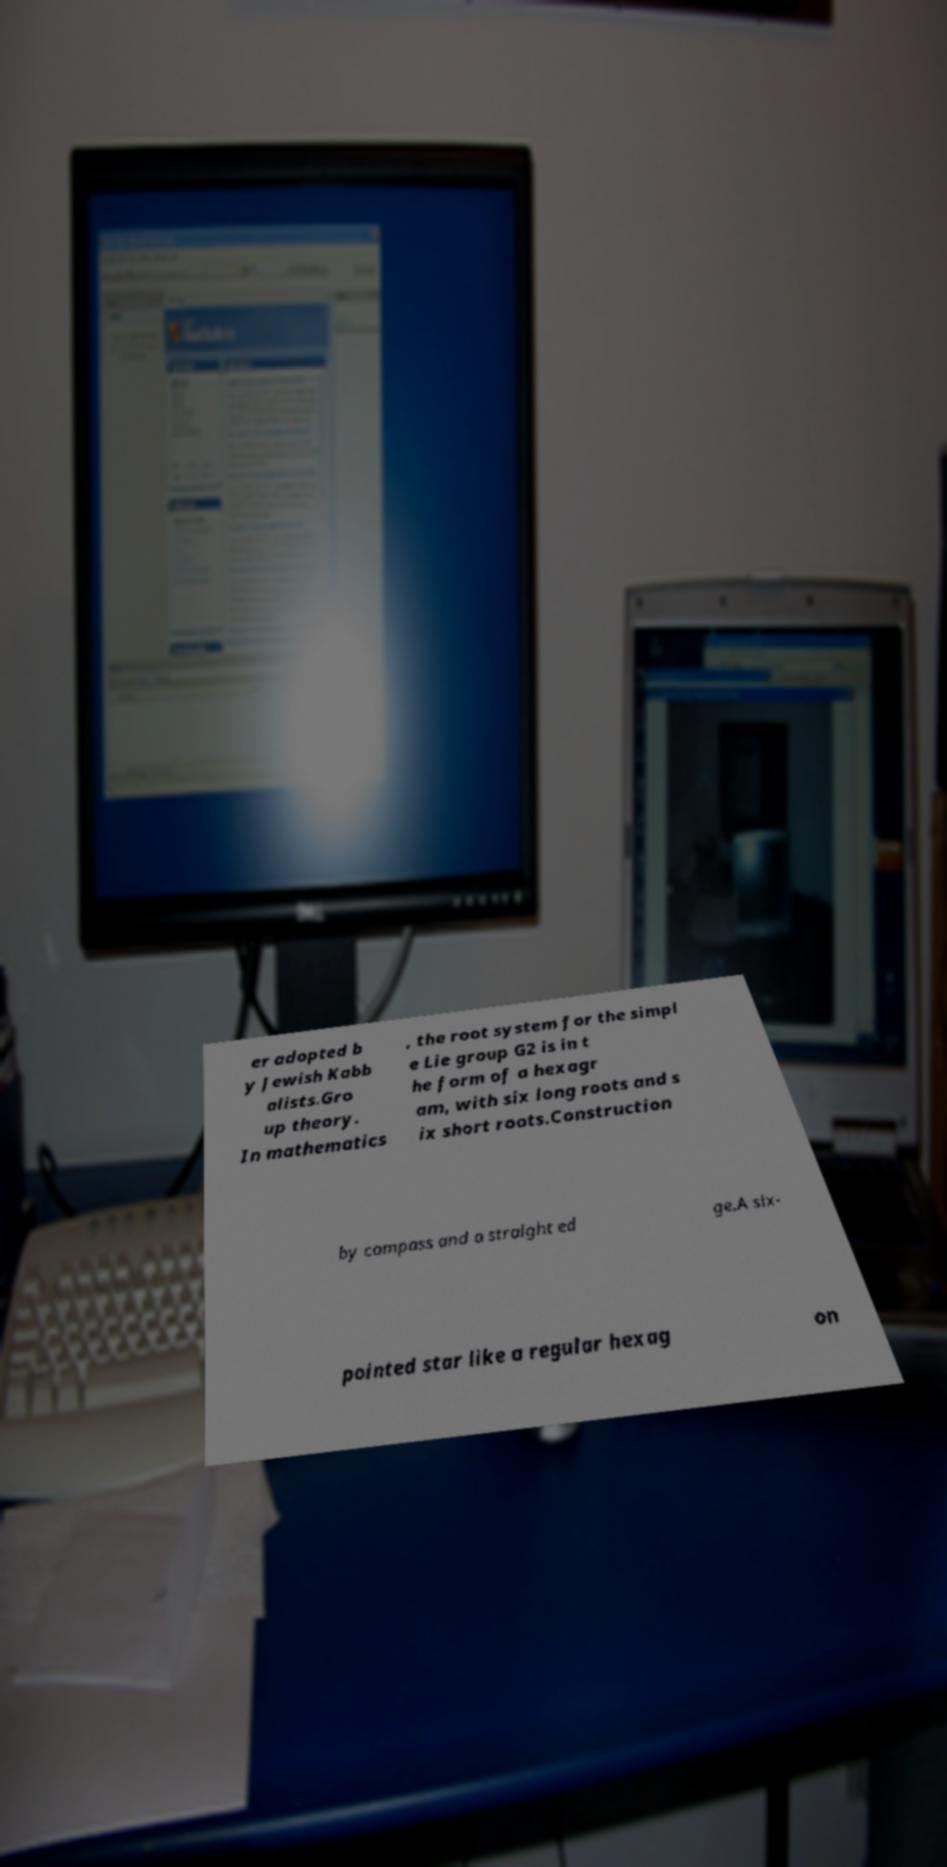I need the written content from this picture converted into text. Can you do that? er adopted b y Jewish Kabb alists.Gro up theory. In mathematics , the root system for the simpl e Lie group G2 is in t he form of a hexagr am, with six long roots and s ix short roots.Construction by compass and a straight ed ge.A six- pointed star like a regular hexag on 